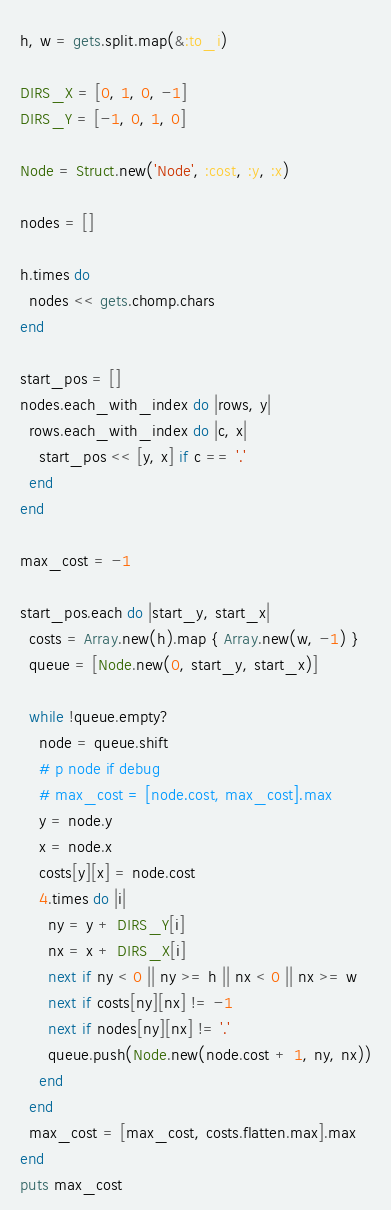<code> <loc_0><loc_0><loc_500><loc_500><_Ruby_>h, w = gets.split.map(&:to_i)

DIRS_X = [0, 1, 0, -1]
DIRS_Y = [-1, 0, 1, 0]

Node = Struct.new('Node', :cost, :y, :x)

nodes = []

h.times do
  nodes << gets.chomp.chars
end

start_pos = []
nodes.each_with_index do |rows, y|
  rows.each_with_index do |c, x|
    start_pos << [y, x] if c == '.'
  end
end

max_cost = -1

start_pos.each do |start_y, start_x|
  costs = Array.new(h).map { Array.new(w, -1) }
  queue = [Node.new(0, start_y, start_x)]

  while !queue.empty?
    node = queue.shift
    # p node if debug
    # max_cost = [node.cost, max_cost].max
    y = node.y
    x = node.x
    costs[y][x] = node.cost
    4.times do |i|
      ny = y + DIRS_Y[i]
      nx = x + DIRS_X[i]
      next if ny < 0 || ny >= h || nx < 0 || nx >= w
      next if costs[ny][nx] != -1
      next if nodes[ny][nx] != '.'
      queue.push(Node.new(node.cost + 1, ny, nx))
    end
  end
  max_cost = [max_cost, costs.flatten.max].max
end
puts max_cost</code> 